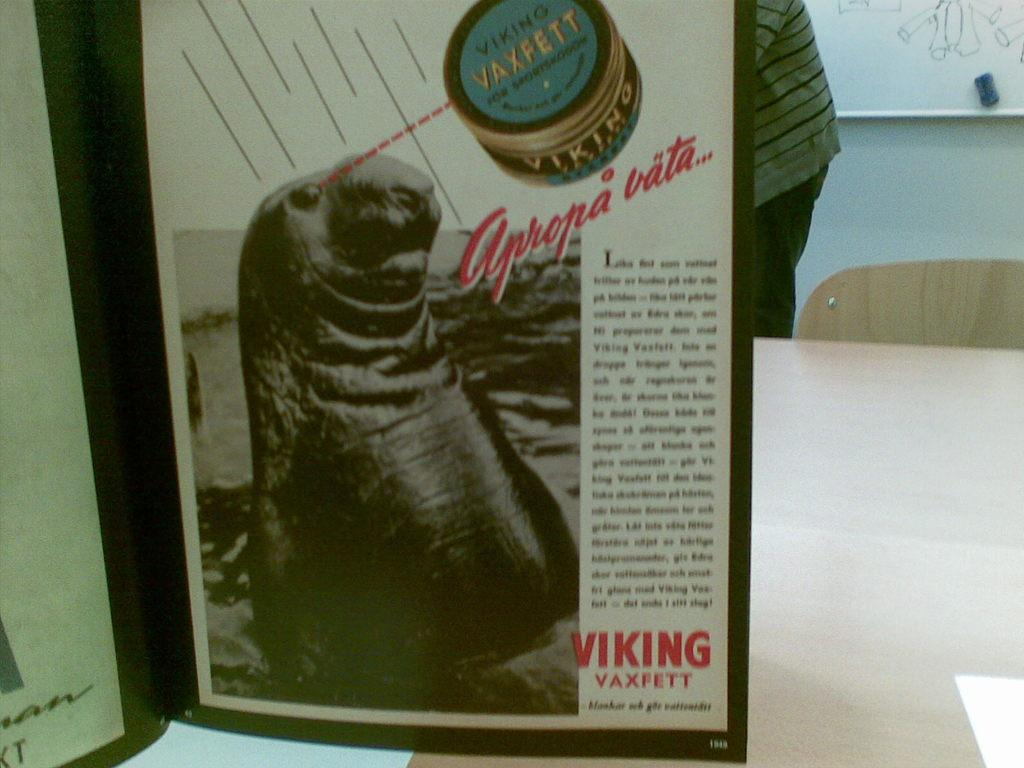<image>
Relay a brief, clear account of the picture shown. An advertisement for Viking Vaxfett shows some kind of seal or sea lion. 